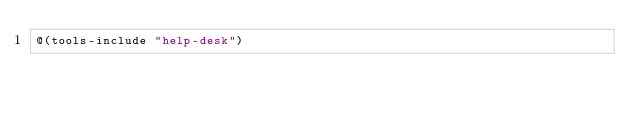<code> <loc_0><loc_0><loc_500><loc_500><_Racket_>@(tools-include "help-desk")
</code> 